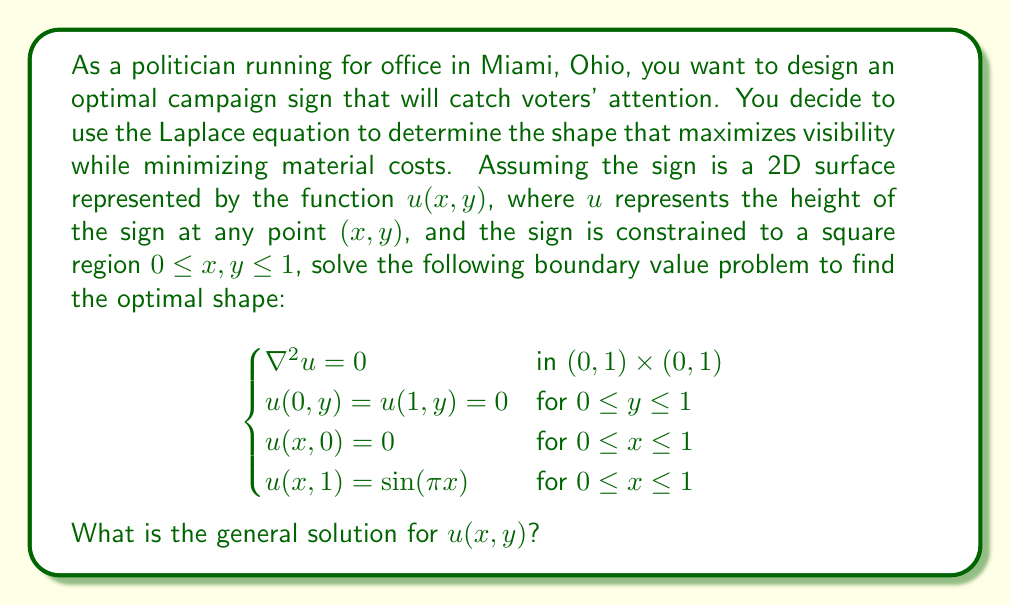What is the answer to this math problem? To solve this problem, we'll use the method of separation of variables:

1) Assume the solution has the form $u(x,y) = X(x)Y(y)$.

2) Substituting this into the Laplace equation $\nabla^2 u = 0$:

   $$X''(x)Y(y) + X(x)Y''(y) = 0$$

3) Dividing by $X(x)Y(y)$:

   $$\frac{X''(x)}{X(x)} = -\frac{Y''(y)}{Y(y)} = -\lambda^2$$

   Where $\lambda^2$ is a constant.

4) This gives us two ODEs:
   
   $X''(x) + \lambda^2 X(x) = 0$
   $Y''(y) - \lambda^2 Y(y) = 0$

5) The general solutions are:
   
   $X(x) = A \cos(\lambda x) + B \sin(\lambda x)$
   $Y(y) = C e^{\lambda y} + D e^{-\lambda y}$

6) Applying the boundary conditions $u(0,y) = u(1,y) = 0$:

   $X(0) = 0 \implies A = 0$
   $X(1) = 0 \implies \sin(\lambda) = 0 \implies \lambda = n\pi, n = 1,2,3,...$

7) The condition $u(x,0) = 0$ implies $C = -D$.

8) Therefore, the general solution is:

   $$u(x,y) = \sum_{n=1}^{\infty} B_n \sin(n\pi x) \sinh(n\pi y)$$

9) To satisfy the final boundary condition $u(x,1) = \sin(\pi x)$, we need:

   $$\sum_{n=1}^{\infty} B_n \sin(n\pi x) \sinh(n\pi) = \sin(\pi x)$$

   This implies $B_1 = \frac{1}{\sinh(\pi)}$ and $B_n = 0$ for $n > 1$.

Therefore, the final solution is:

$$u(x,y) = \frac{\sinh(\pi y)}{\sinh(\pi)} \sin(\pi x)$$

This solution represents the optimal shape of the campaign sign, maximizing visibility while minimizing material costs.
Answer: $$u(x,y) = \frac{\sinh(\pi y)}{\sinh(\pi)} \sin(\pi x)$$ 